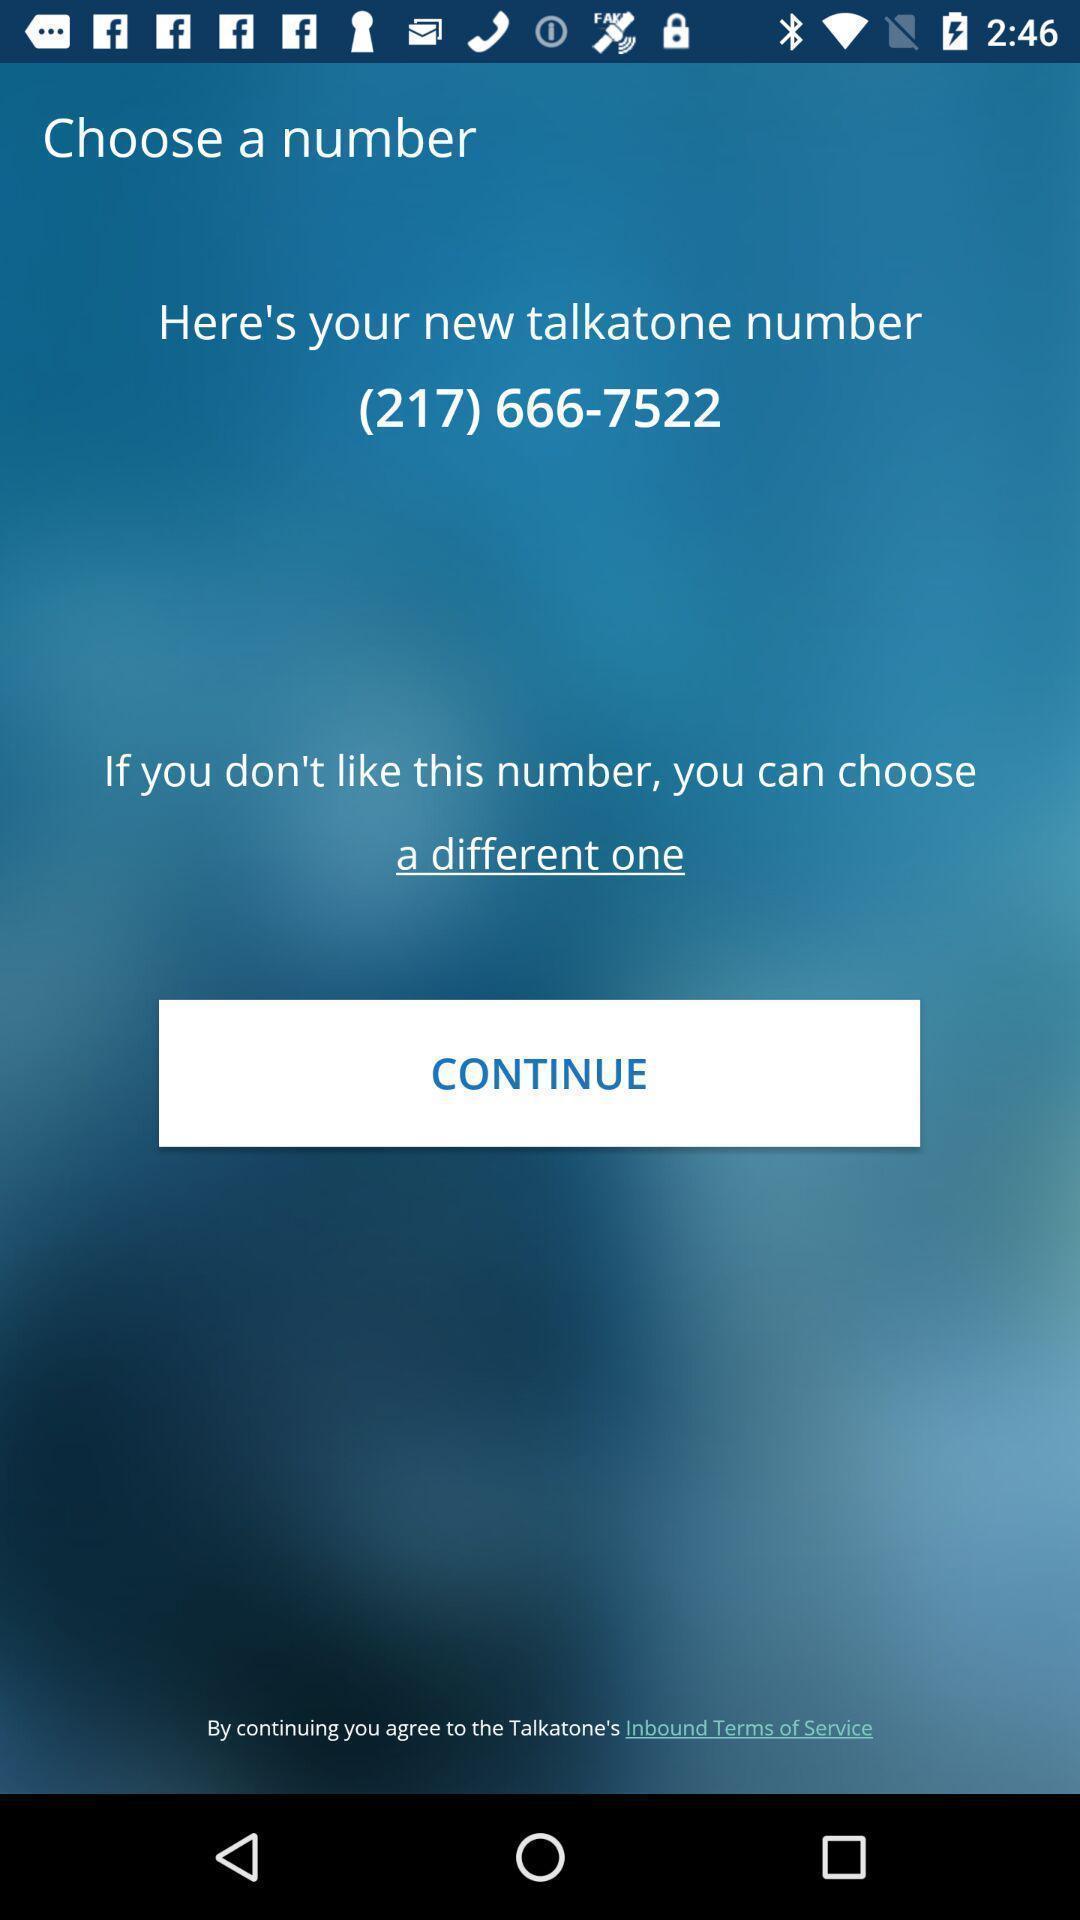Give me a summary of this screen capture. Welcome page with new number in a calling app. 